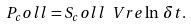<formula> <loc_0><loc_0><loc_500><loc_500>P _ { c } o l l = S _ { c } o l l \ V r e \ln \, \delta t .</formula> 